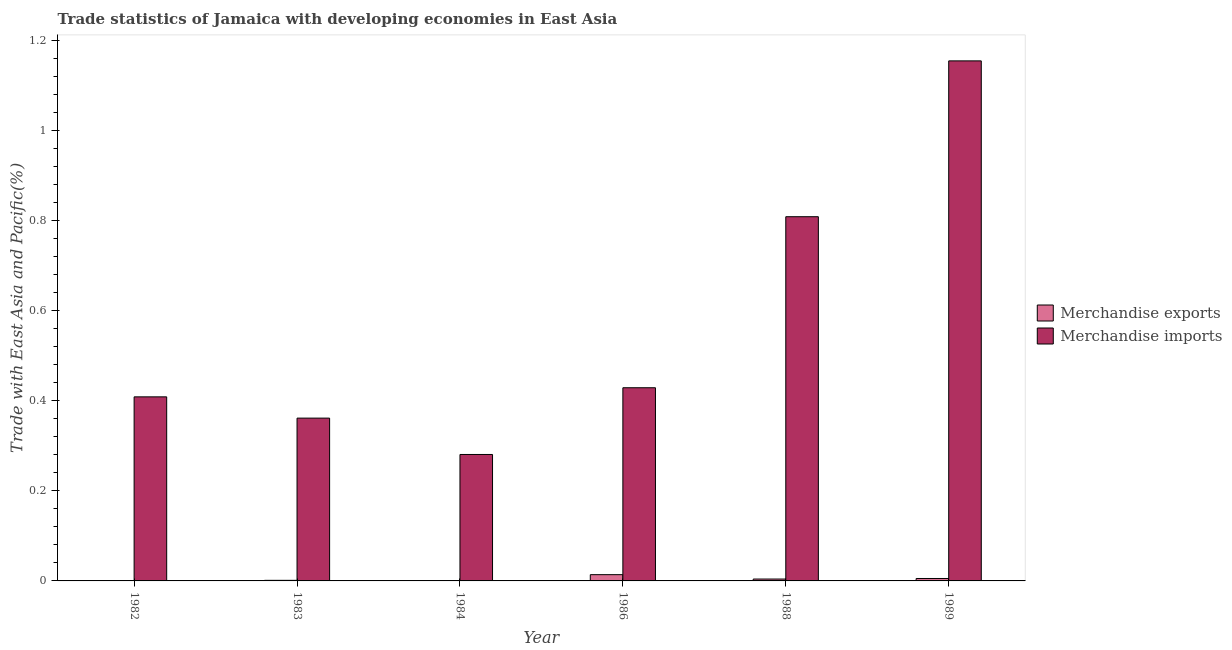Are the number of bars per tick equal to the number of legend labels?
Offer a terse response. Yes. What is the merchandise imports in 1989?
Your answer should be compact. 1.16. Across all years, what is the maximum merchandise exports?
Your answer should be very brief. 0.01. Across all years, what is the minimum merchandise exports?
Keep it short and to the point. 0. In which year was the merchandise imports maximum?
Your answer should be very brief. 1989. What is the total merchandise exports in the graph?
Offer a very short reply. 0.03. What is the difference between the merchandise exports in 1984 and that in 1986?
Provide a short and direct response. -0.01. What is the difference between the merchandise imports in 1986 and the merchandise exports in 1982?
Make the answer very short. 0.02. What is the average merchandise imports per year?
Provide a succinct answer. 0.57. What is the ratio of the merchandise exports in 1986 to that in 1989?
Offer a very short reply. 2.57. Is the difference between the merchandise imports in 1982 and 1988 greater than the difference between the merchandise exports in 1982 and 1988?
Your answer should be very brief. No. What is the difference between the highest and the second highest merchandise imports?
Your answer should be very brief. 0.35. What is the difference between the highest and the lowest merchandise exports?
Your answer should be very brief. 0.01. Is the sum of the merchandise imports in 1986 and 1989 greater than the maximum merchandise exports across all years?
Ensure brevity in your answer.  Yes. What does the 2nd bar from the right in 1989 represents?
Ensure brevity in your answer.  Merchandise exports. What is the difference between two consecutive major ticks on the Y-axis?
Keep it short and to the point. 0.2. Are the values on the major ticks of Y-axis written in scientific E-notation?
Ensure brevity in your answer.  No. Does the graph contain grids?
Provide a short and direct response. No. What is the title of the graph?
Your response must be concise. Trade statistics of Jamaica with developing economies in East Asia. What is the label or title of the X-axis?
Offer a terse response. Year. What is the label or title of the Y-axis?
Make the answer very short. Trade with East Asia and Pacific(%). What is the Trade with East Asia and Pacific(%) in Merchandise exports in 1982?
Ensure brevity in your answer.  0. What is the Trade with East Asia and Pacific(%) in Merchandise imports in 1982?
Keep it short and to the point. 0.41. What is the Trade with East Asia and Pacific(%) in Merchandise exports in 1983?
Provide a succinct answer. 0. What is the Trade with East Asia and Pacific(%) in Merchandise imports in 1983?
Offer a very short reply. 0.36. What is the Trade with East Asia and Pacific(%) of Merchandise exports in 1984?
Ensure brevity in your answer.  0. What is the Trade with East Asia and Pacific(%) of Merchandise imports in 1984?
Ensure brevity in your answer.  0.28. What is the Trade with East Asia and Pacific(%) in Merchandise exports in 1986?
Give a very brief answer. 0.01. What is the Trade with East Asia and Pacific(%) in Merchandise imports in 1986?
Ensure brevity in your answer.  0.43. What is the Trade with East Asia and Pacific(%) of Merchandise exports in 1988?
Offer a terse response. 0. What is the Trade with East Asia and Pacific(%) in Merchandise imports in 1988?
Provide a succinct answer. 0.81. What is the Trade with East Asia and Pacific(%) of Merchandise exports in 1989?
Offer a very short reply. 0.01. What is the Trade with East Asia and Pacific(%) of Merchandise imports in 1989?
Provide a succinct answer. 1.16. Across all years, what is the maximum Trade with East Asia and Pacific(%) in Merchandise exports?
Provide a succinct answer. 0.01. Across all years, what is the maximum Trade with East Asia and Pacific(%) in Merchandise imports?
Your response must be concise. 1.16. Across all years, what is the minimum Trade with East Asia and Pacific(%) of Merchandise exports?
Give a very brief answer. 0. Across all years, what is the minimum Trade with East Asia and Pacific(%) of Merchandise imports?
Ensure brevity in your answer.  0.28. What is the total Trade with East Asia and Pacific(%) in Merchandise exports in the graph?
Your answer should be very brief. 0.03. What is the total Trade with East Asia and Pacific(%) in Merchandise imports in the graph?
Your answer should be compact. 3.45. What is the difference between the Trade with East Asia and Pacific(%) of Merchandise exports in 1982 and that in 1983?
Your answer should be very brief. -0. What is the difference between the Trade with East Asia and Pacific(%) of Merchandise imports in 1982 and that in 1983?
Keep it short and to the point. 0.05. What is the difference between the Trade with East Asia and Pacific(%) of Merchandise exports in 1982 and that in 1984?
Ensure brevity in your answer.  -0. What is the difference between the Trade with East Asia and Pacific(%) in Merchandise imports in 1982 and that in 1984?
Provide a succinct answer. 0.13. What is the difference between the Trade with East Asia and Pacific(%) of Merchandise exports in 1982 and that in 1986?
Your answer should be compact. -0.01. What is the difference between the Trade with East Asia and Pacific(%) of Merchandise imports in 1982 and that in 1986?
Make the answer very short. -0.02. What is the difference between the Trade with East Asia and Pacific(%) of Merchandise exports in 1982 and that in 1988?
Give a very brief answer. -0. What is the difference between the Trade with East Asia and Pacific(%) of Merchandise imports in 1982 and that in 1988?
Provide a succinct answer. -0.4. What is the difference between the Trade with East Asia and Pacific(%) of Merchandise exports in 1982 and that in 1989?
Give a very brief answer. -0.01. What is the difference between the Trade with East Asia and Pacific(%) of Merchandise imports in 1982 and that in 1989?
Provide a succinct answer. -0.75. What is the difference between the Trade with East Asia and Pacific(%) in Merchandise exports in 1983 and that in 1984?
Your answer should be compact. 0. What is the difference between the Trade with East Asia and Pacific(%) in Merchandise imports in 1983 and that in 1984?
Your response must be concise. 0.08. What is the difference between the Trade with East Asia and Pacific(%) of Merchandise exports in 1983 and that in 1986?
Your answer should be very brief. -0.01. What is the difference between the Trade with East Asia and Pacific(%) in Merchandise imports in 1983 and that in 1986?
Provide a succinct answer. -0.07. What is the difference between the Trade with East Asia and Pacific(%) of Merchandise exports in 1983 and that in 1988?
Ensure brevity in your answer.  -0. What is the difference between the Trade with East Asia and Pacific(%) in Merchandise imports in 1983 and that in 1988?
Give a very brief answer. -0.45. What is the difference between the Trade with East Asia and Pacific(%) of Merchandise exports in 1983 and that in 1989?
Your response must be concise. -0. What is the difference between the Trade with East Asia and Pacific(%) of Merchandise imports in 1983 and that in 1989?
Offer a terse response. -0.79. What is the difference between the Trade with East Asia and Pacific(%) in Merchandise exports in 1984 and that in 1986?
Make the answer very short. -0.01. What is the difference between the Trade with East Asia and Pacific(%) in Merchandise imports in 1984 and that in 1986?
Provide a succinct answer. -0.15. What is the difference between the Trade with East Asia and Pacific(%) of Merchandise exports in 1984 and that in 1988?
Give a very brief answer. -0. What is the difference between the Trade with East Asia and Pacific(%) of Merchandise imports in 1984 and that in 1988?
Your answer should be compact. -0.53. What is the difference between the Trade with East Asia and Pacific(%) in Merchandise exports in 1984 and that in 1989?
Your answer should be very brief. -0.01. What is the difference between the Trade with East Asia and Pacific(%) of Merchandise imports in 1984 and that in 1989?
Offer a very short reply. -0.87. What is the difference between the Trade with East Asia and Pacific(%) of Merchandise exports in 1986 and that in 1988?
Ensure brevity in your answer.  0.01. What is the difference between the Trade with East Asia and Pacific(%) in Merchandise imports in 1986 and that in 1988?
Ensure brevity in your answer.  -0.38. What is the difference between the Trade with East Asia and Pacific(%) in Merchandise exports in 1986 and that in 1989?
Keep it short and to the point. 0.01. What is the difference between the Trade with East Asia and Pacific(%) of Merchandise imports in 1986 and that in 1989?
Offer a terse response. -0.73. What is the difference between the Trade with East Asia and Pacific(%) of Merchandise exports in 1988 and that in 1989?
Make the answer very short. -0. What is the difference between the Trade with East Asia and Pacific(%) in Merchandise imports in 1988 and that in 1989?
Provide a succinct answer. -0.35. What is the difference between the Trade with East Asia and Pacific(%) of Merchandise exports in 1982 and the Trade with East Asia and Pacific(%) of Merchandise imports in 1983?
Provide a succinct answer. -0.36. What is the difference between the Trade with East Asia and Pacific(%) of Merchandise exports in 1982 and the Trade with East Asia and Pacific(%) of Merchandise imports in 1984?
Give a very brief answer. -0.28. What is the difference between the Trade with East Asia and Pacific(%) in Merchandise exports in 1982 and the Trade with East Asia and Pacific(%) in Merchandise imports in 1986?
Provide a short and direct response. -0.43. What is the difference between the Trade with East Asia and Pacific(%) in Merchandise exports in 1982 and the Trade with East Asia and Pacific(%) in Merchandise imports in 1988?
Keep it short and to the point. -0.81. What is the difference between the Trade with East Asia and Pacific(%) of Merchandise exports in 1982 and the Trade with East Asia and Pacific(%) of Merchandise imports in 1989?
Give a very brief answer. -1.16. What is the difference between the Trade with East Asia and Pacific(%) of Merchandise exports in 1983 and the Trade with East Asia and Pacific(%) of Merchandise imports in 1984?
Make the answer very short. -0.28. What is the difference between the Trade with East Asia and Pacific(%) in Merchandise exports in 1983 and the Trade with East Asia and Pacific(%) in Merchandise imports in 1986?
Your answer should be compact. -0.43. What is the difference between the Trade with East Asia and Pacific(%) in Merchandise exports in 1983 and the Trade with East Asia and Pacific(%) in Merchandise imports in 1988?
Give a very brief answer. -0.81. What is the difference between the Trade with East Asia and Pacific(%) of Merchandise exports in 1983 and the Trade with East Asia and Pacific(%) of Merchandise imports in 1989?
Offer a terse response. -1.15. What is the difference between the Trade with East Asia and Pacific(%) of Merchandise exports in 1984 and the Trade with East Asia and Pacific(%) of Merchandise imports in 1986?
Keep it short and to the point. -0.43. What is the difference between the Trade with East Asia and Pacific(%) of Merchandise exports in 1984 and the Trade with East Asia and Pacific(%) of Merchandise imports in 1988?
Your answer should be very brief. -0.81. What is the difference between the Trade with East Asia and Pacific(%) of Merchandise exports in 1984 and the Trade with East Asia and Pacific(%) of Merchandise imports in 1989?
Provide a short and direct response. -1.16. What is the difference between the Trade with East Asia and Pacific(%) of Merchandise exports in 1986 and the Trade with East Asia and Pacific(%) of Merchandise imports in 1988?
Ensure brevity in your answer.  -0.8. What is the difference between the Trade with East Asia and Pacific(%) in Merchandise exports in 1986 and the Trade with East Asia and Pacific(%) in Merchandise imports in 1989?
Your answer should be very brief. -1.14. What is the difference between the Trade with East Asia and Pacific(%) in Merchandise exports in 1988 and the Trade with East Asia and Pacific(%) in Merchandise imports in 1989?
Your answer should be compact. -1.15. What is the average Trade with East Asia and Pacific(%) of Merchandise exports per year?
Keep it short and to the point. 0. What is the average Trade with East Asia and Pacific(%) of Merchandise imports per year?
Ensure brevity in your answer.  0.57. In the year 1982, what is the difference between the Trade with East Asia and Pacific(%) of Merchandise exports and Trade with East Asia and Pacific(%) of Merchandise imports?
Provide a short and direct response. -0.41. In the year 1983, what is the difference between the Trade with East Asia and Pacific(%) of Merchandise exports and Trade with East Asia and Pacific(%) of Merchandise imports?
Keep it short and to the point. -0.36. In the year 1984, what is the difference between the Trade with East Asia and Pacific(%) in Merchandise exports and Trade with East Asia and Pacific(%) in Merchandise imports?
Ensure brevity in your answer.  -0.28. In the year 1986, what is the difference between the Trade with East Asia and Pacific(%) of Merchandise exports and Trade with East Asia and Pacific(%) of Merchandise imports?
Offer a terse response. -0.42. In the year 1988, what is the difference between the Trade with East Asia and Pacific(%) of Merchandise exports and Trade with East Asia and Pacific(%) of Merchandise imports?
Your answer should be very brief. -0.81. In the year 1989, what is the difference between the Trade with East Asia and Pacific(%) in Merchandise exports and Trade with East Asia and Pacific(%) in Merchandise imports?
Provide a short and direct response. -1.15. What is the ratio of the Trade with East Asia and Pacific(%) of Merchandise exports in 1982 to that in 1983?
Keep it short and to the point. 0.1. What is the ratio of the Trade with East Asia and Pacific(%) in Merchandise imports in 1982 to that in 1983?
Your response must be concise. 1.13. What is the ratio of the Trade with East Asia and Pacific(%) in Merchandise exports in 1982 to that in 1984?
Keep it short and to the point. 0.97. What is the ratio of the Trade with East Asia and Pacific(%) in Merchandise imports in 1982 to that in 1984?
Ensure brevity in your answer.  1.46. What is the ratio of the Trade with East Asia and Pacific(%) of Merchandise exports in 1982 to that in 1986?
Keep it short and to the point. 0.01. What is the ratio of the Trade with East Asia and Pacific(%) in Merchandise imports in 1982 to that in 1986?
Provide a succinct answer. 0.95. What is the ratio of the Trade with East Asia and Pacific(%) in Merchandise exports in 1982 to that in 1988?
Offer a very short reply. 0.03. What is the ratio of the Trade with East Asia and Pacific(%) in Merchandise imports in 1982 to that in 1988?
Ensure brevity in your answer.  0.51. What is the ratio of the Trade with East Asia and Pacific(%) in Merchandise exports in 1982 to that in 1989?
Provide a succinct answer. 0.02. What is the ratio of the Trade with East Asia and Pacific(%) of Merchandise imports in 1982 to that in 1989?
Offer a terse response. 0.35. What is the ratio of the Trade with East Asia and Pacific(%) in Merchandise exports in 1983 to that in 1984?
Provide a short and direct response. 9.76. What is the ratio of the Trade with East Asia and Pacific(%) of Merchandise imports in 1983 to that in 1984?
Make the answer very short. 1.29. What is the ratio of the Trade with East Asia and Pacific(%) of Merchandise exports in 1983 to that in 1986?
Your answer should be very brief. 0.09. What is the ratio of the Trade with East Asia and Pacific(%) of Merchandise imports in 1983 to that in 1986?
Give a very brief answer. 0.84. What is the ratio of the Trade with East Asia and Pacific(%) in Merchandise exports in 1983 to that in 1988?
Your response must be concise. 0.31. What is the ratio of the Trade with East Asia and Pacific(%) in Merchandise imports in 1983 to that in 1988?
Provide a short and direct response. 0.45. What is the ratio of the Trade with East Asia and Pacific(%) in Merchandise exports in 1983 to that in 1989?
Ensure brevity in your answer.  0.24. What is the ratio of the Trade with East Asia and Pacific(%) of Merchandise imports in 1983 to that in 1989?
Ensure brevity in your answer.  0.31. What is the ratio of the Trade with East Asia and Pacific(%) of Merchandise exports in 1984 to that in 1986?
Your response must be concise. 0.01. What is the ratio of the Trade with East Asia and Pacific(%) of Merchandise imports in 1984 to that in 1986?
Ensure brevity in your answer.  0.65. What is the ratio of the Trade with East Asia and Pacific(%) in Merchandise exports in 1984 to that in 1988?
Your response must be concise. 0.03. What is the ratio of the Trade with East Asia and Pacific(%) of Merchandise imports in 1984 to that in 1988?
Your answer should be very brief. 0.35. What is the ratio of the Trade with East Asia and Pacific(%) of Merchandise exports in 1984 to that in 1989?
Your answer should be very brief. 0.02. What is the ratio of the Trade with East Asia and Pacific(%) of Merchandise imports in 1984 to that in 1989?
Give a very brief answer. 0.24. What is the ratio of the Trade with East Asia and Pacific(%) of Merchandise exports in 1986 to that in 1988?
Provide a succinct answer. 3.32. What is the ratio of the Trade with East Asia and Pacific(%) of Merchandise imports in 1986 to that in 1988?
Your answer should be very brief. 0.53. What is the ratio of the Trade with East Asia and Pacific(%) in Merchandise exports in 1986 to that in 1989?
Ensure brevity in your answer.  2.57. What is the ratio of the Trade with East Asia and Pacific(%) in Merchandise imports in 1986 to that in 1989?
Your response must be concise. 0.37. What is the ratio of the Trade with East Asia and Pacific(%) in Merchandise exports in 1988 to that in 1989?
Make the answer very short. 0.77. What is the ratio of the Trade with East Asia and Pacific(%) of Merchandise imports in 1988 to that in 1989?
Provide a short and direct response. 0.7. What is the difference between the highest and the second highest Trade with East Asia and Pacific(%) of Merchandise exports?
Provide a succinct answer. 0.01. What is the difference between the highest and the second highest Trade with East Asia and Pacific(%) in Merchandise imports?
Provide a short and direct response. 0.35. What is the difference between the highest and the lowest Trade with East Asia and Pacific(%) in Merchandise exports?
Offer a very short reply. 0.01. What is the difference between the highest and the lowest Trade with East Asia and Pacific(%) of Merchandise imports?
Provide a succinct answer. 0.87. 